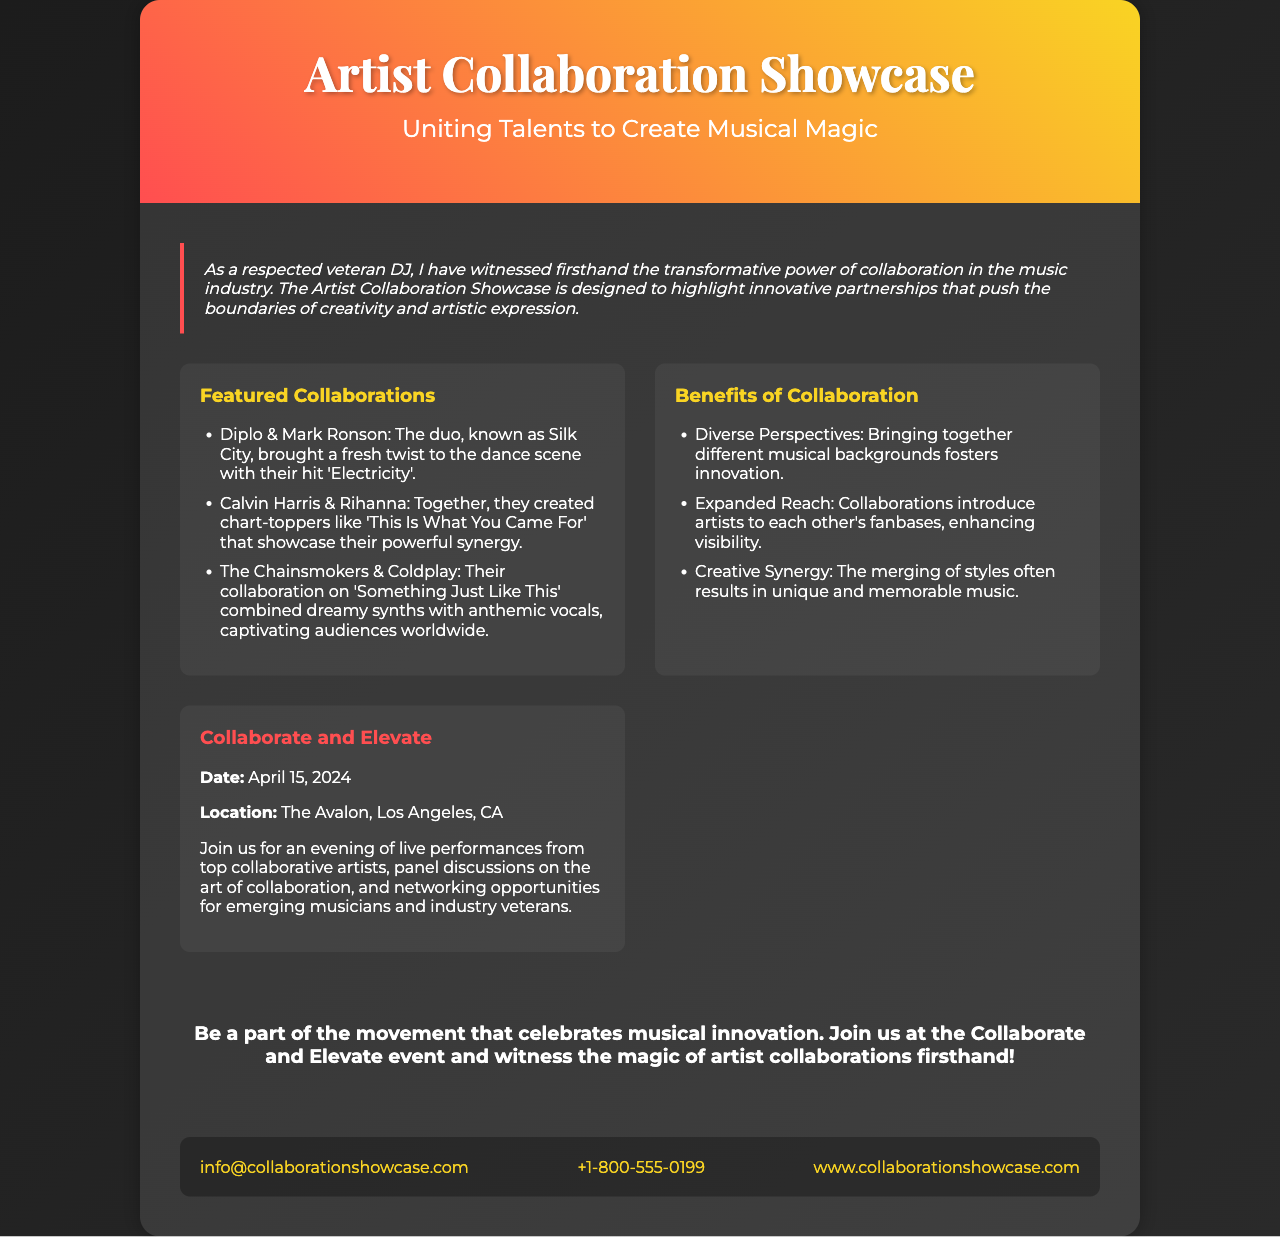What is the title of the event? The title of the event is stated in the header of the brochure.
Answer: Artist Collaboration Showcase When is the event taking place? The date of the event is clearly mentioned in the showcase event section.
Answer: April 15, 2024 Where will the event be held? The location of the event is presented in the showcase event details.
Answer: The Avalon, Los Angeles, CA Which collaboration produced the hit 'Electricity'? This information is provided under the featured collaborations section in the document.
Answer: Diplo & Mark Ronson What is one benefit of collaboration mentioned? The document lists multiple benefits of collaboration under the specific section.
Answer: Diverse Perspectives How do collaborations enhance visibility? This reasoning is found in the benefits section highlighting how collaborations introduce artists to each other’s fanbases.
Answer: Expanded Reach What is the main theme of the brochure? The introduction outlines the purpose of the brochure and the event focus.
Answer: Musical Innovation Who can participate in the networking opportunities? The target audience for networking is mentioned in relation to the event overview.
Answer: Emerging musicians and industry veterans What kind of discussions will occur at the event? The type of discussions taking place is specified in the showcase event description.
Answer: Panel discussions on the art of collaboration 